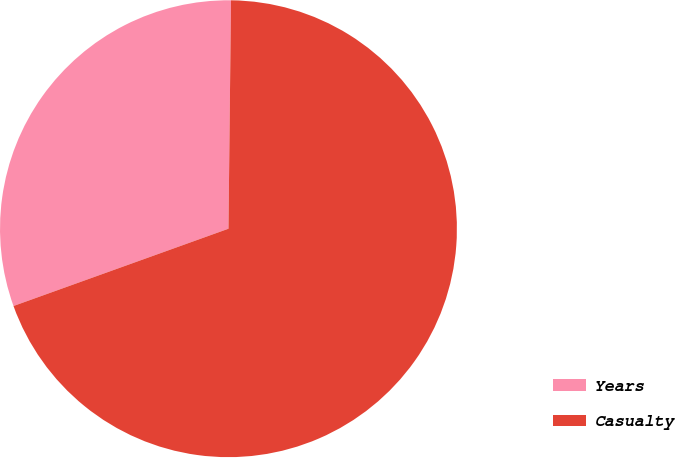<chart> <loc_0><loc_0><loc_500><loc_500><pie_chart><fcel>Years<fcel>Casualty<nl><fcel>30.67%<fcel>69.33%<nl></chart> 